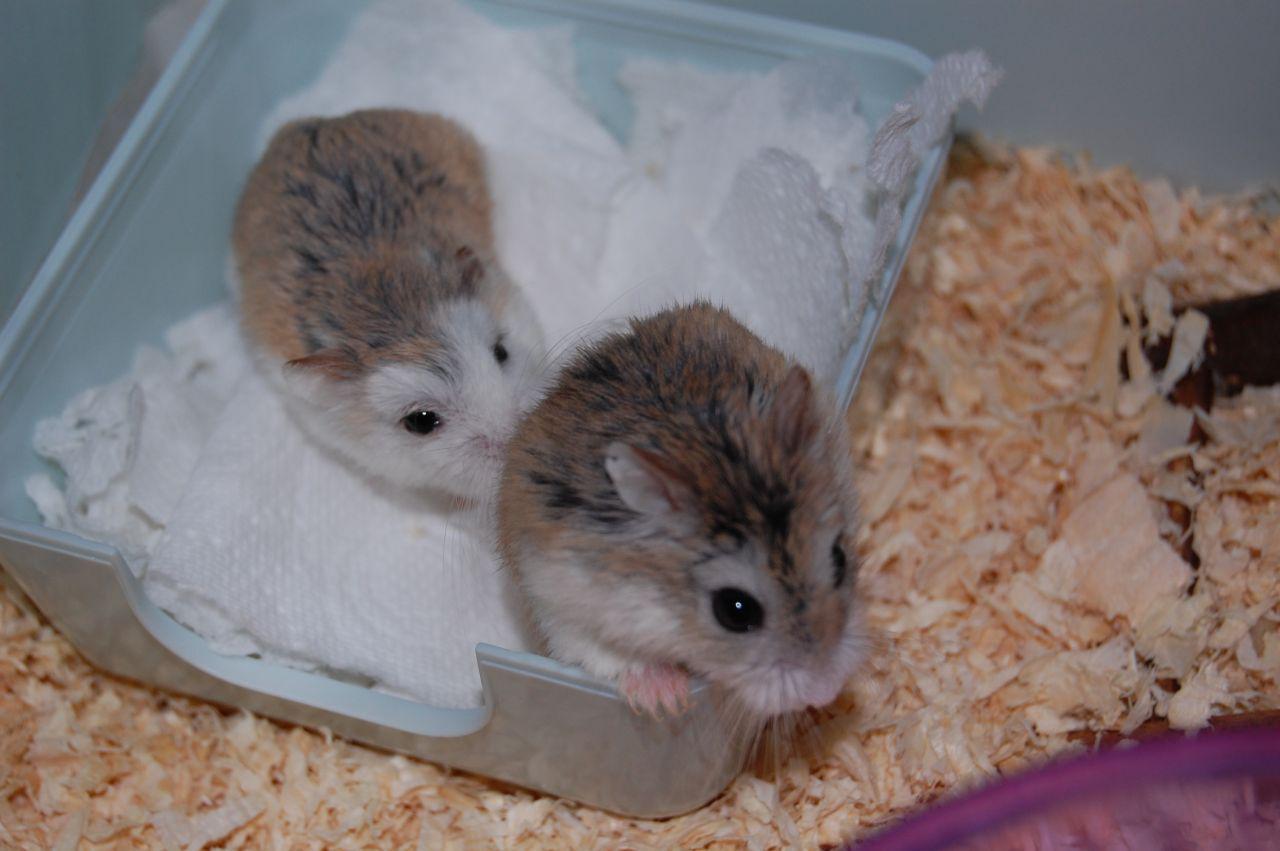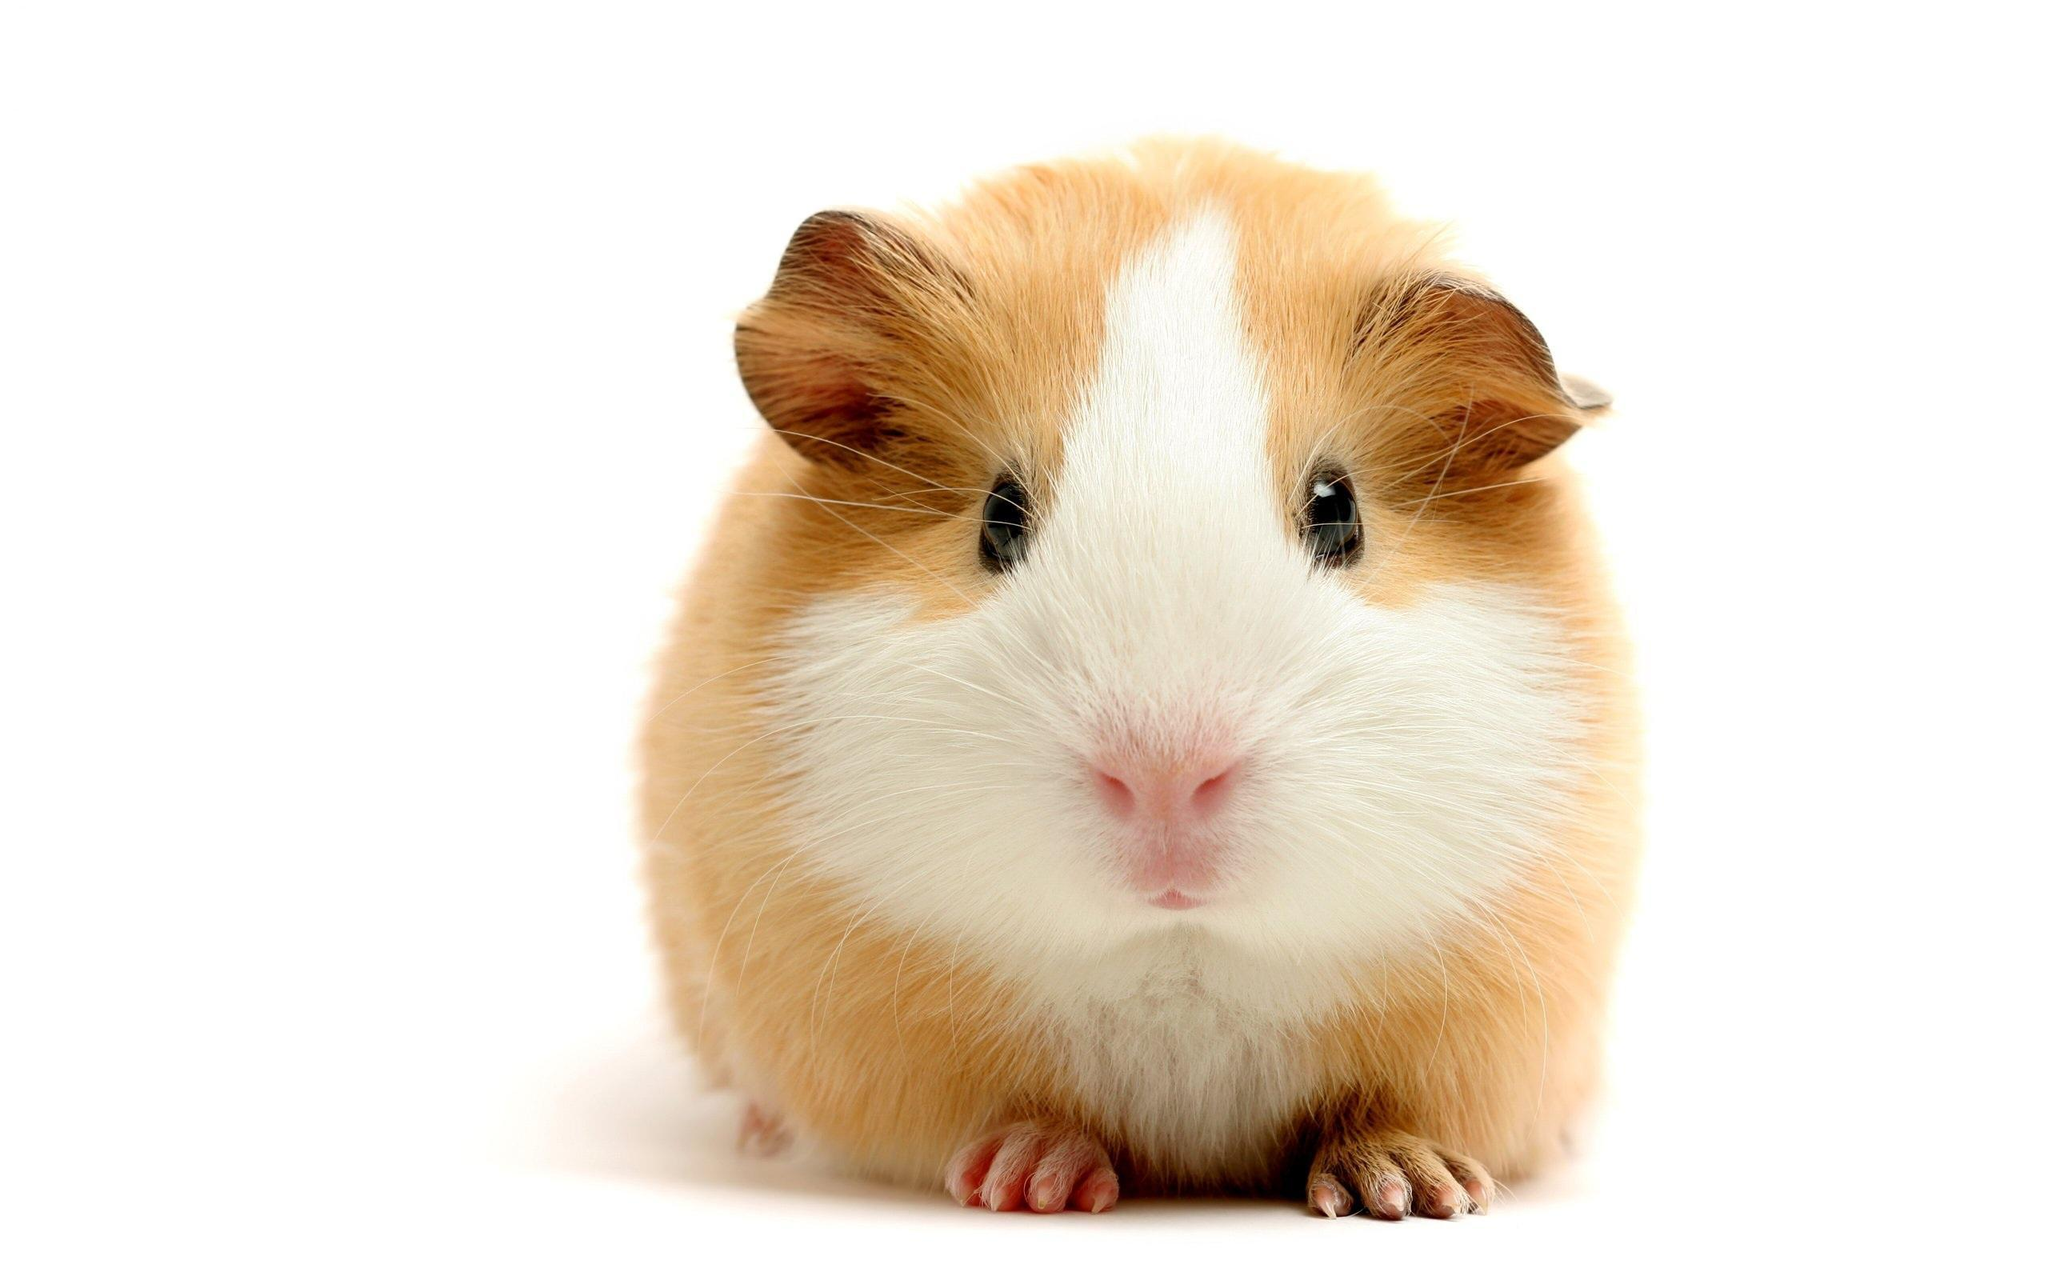The first image is the image on the left, the second image is the image on the right. Given the left and right images, does the statement "In one of the images there are two hamsters." hold true? Answer yes or no. Yes. 